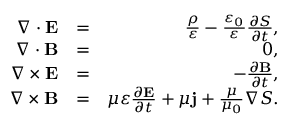Convert formula to latex. <formula><loc_0><loc_0><loc_500><loc_500>\begin{array} { r l r } { \nabla \cdot E } & { = } & { \frac { \rho } { \varepsilon } - \frac { \varepsilon _ { 0 } } { \varepsilon } \frac { \partial S } { \partial t } , } \\ { \nabla \cdot B } & { = } & { 0 , } \\ { \nabla \times E } & { = } & { - \frac { \partial B } { \partial t } , } \\ { \nabla \times B } & { = } & { \mu \varepsilon \frac { \partial E } { \partial t } + \mu j + \frac { \mu } { \mu _ { 0 } } \nabla S . } \end{array}</formula> 